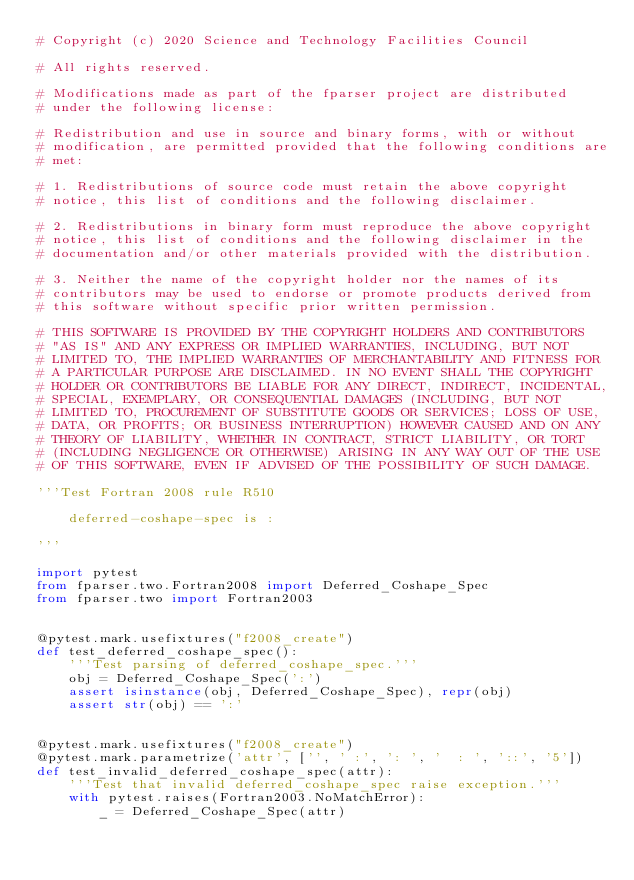Convert code to text. <code><loc_0><loc_0><loc_500><loc_500><_Python_># Copyright (c) 2020 Science and Technology Facilities Council

# All rights reserved.

# Modifications made as part of the fparser project are distributed
# under the following license:

# Redistribution and use in source and binary forms, with or without
# modification, are permitted provided that the following conditions are
# met:

# 1. Redistributions of source code must retain the above copyright
# notice, this list of conditions and the following disclaimer.

# 2. Redistributions in binary form must reproduce the above copyright
# notice, this list of conditions and the following disclaimer in the
# documentation and/or other materials provided with the distribution.

# 3. Neither the name of the copyright holder nor the names of its
# contributors may be used to endorse or promote products derived from
# this software without specific prior written permission.

# THIS SOFTWARE IS PROVIDED BY THE COPYRIGHT HOLDERS AND CONTRIBUTORS
# "AS IS" AND ANY EXPRESS OR IMPLIED WARRANTIES, INCLUDING, BUT NOT
# LIMITED TO, THE IMPLIED WARRANTIES OF MERCHANTABILITY AND FITNESS FOR
# A PARTICULAR PURPOSE ARE DISCLAIMED. IN NO EVENT SHALL THE COPYRIGHT
# HOLDER OR CONTRIBUTORS BE LIABLE FOR ANY DIRECT, INDIRECT, INCIDENTAL,
# SPECIAL, EXEMPLARY, OR CONSEQUENTIAL DAMAGES (INCLUDING, BUT NOT
# LIMITED TO, PROCUREMENT OF SUBSTITUTE GOODS OR SERVICES; LOSS OF USE,
# DATA, OR PROFITS; OR BUSINESS INTERRUPTION) HOWEVER CAUSED AND ON ANY
# THEORY OF LIABILITY, WHETHER IN CONTRACT, STRICT LIABILITY, OR TORT
# (INCLUDING NEGLIGENCE OR OTHERWISE) ARISING IN ANY WAY OUT OF THE USE
# OF THIS SOFTWARE, EVEN IF ADVISED OF THE POSSIBILITY OF SUCH DAMAGE.

'''Test Fortran 2008 rule R510

    deferred-coshape-spec is :

'''

import pytest
from fparser.two.Fortran2008 import Deferred_Coshape_Spec
from fparser.two import Fortran2003


@pytest.mark.usefixtures("f2008_create")
def test_deferred_coshape_spec():
    '''Test parsing of deferred_coshape_spec.'''
    obj = Deferred_Coshape_Spec(':')
    assert isinstance(obj, Deferred_Coshape_Spec), repr(obj)
    assert str(obj) == ':'


@pytest.mark.usefixtures("f2008_create")
@pytest.mark.parametrize('attr', ['', ' :', ': ', '  : ', '::', '5'])
def test_invalid_deferred_coshape_spec(attr):
    '''Test that invalid deferred_coshape_spec raise exception.'''
    with pytest.raises(Fortran2003.NoMatchError):
        _ = Deferred_Coshape_Spec(attr)
</code> 